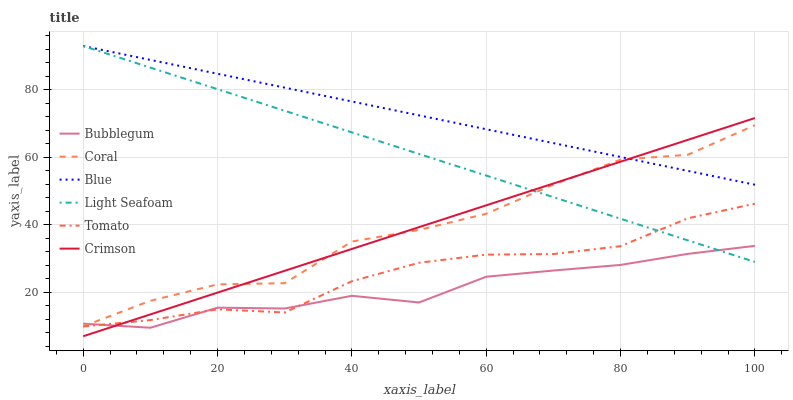Does Bubblegum have the minimum area under the curve?
Answer yes or no. Yes. Does Blue have the maximum area under the curve?
Answer yes or no. Yes. Does Tomato have the minimum area under the curve?
Answer yes or no. No. Does Tomato have the maximum area under the curve?
Answer yes or no. No. Is Light Seafoam the smoothest?
Answer yes or no. Yes. Is Coral the roughest?
Answer yes or no. Yes. Is Tomato the smoothest?
Answer yes or no. No. Is Tomato the roughest?
Answer yes or no. No. Does Crimson have the lowest value?
Answer yes or no. Yes. Does Tomato have the lowest value?
Answer yes or no. No. Does Light Seafoam have the highest value?
Answer yes or no. Yes. Does Tomato have the highest value?
Answer yes or no. No. Is Tomato less than Blue?
Answer yes or no. Yes. Is Blue greater than Bubblegum?
Answer yes or no. Yes. Does Crimson intersect Light Seafoam?
Answer yes or no. Yes. Is Crimson less than Light Seafoam?
Answer yes or no. No. Is Crimson greater than Light Seafoam?
Answer yes or no. No. Does Tomato intersect Blue?
Answer yes or no. No. 